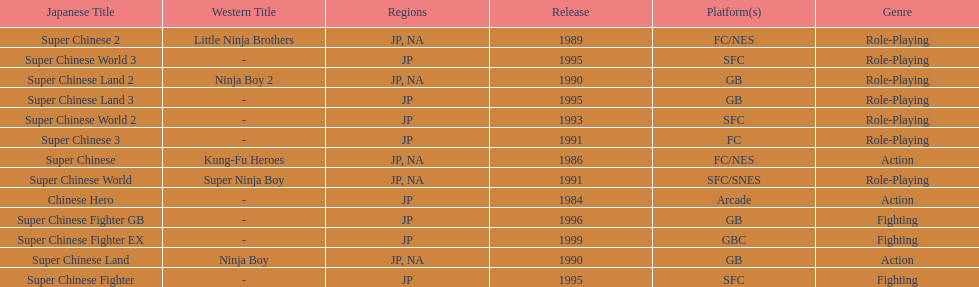Number of super chinese world games released 3. 